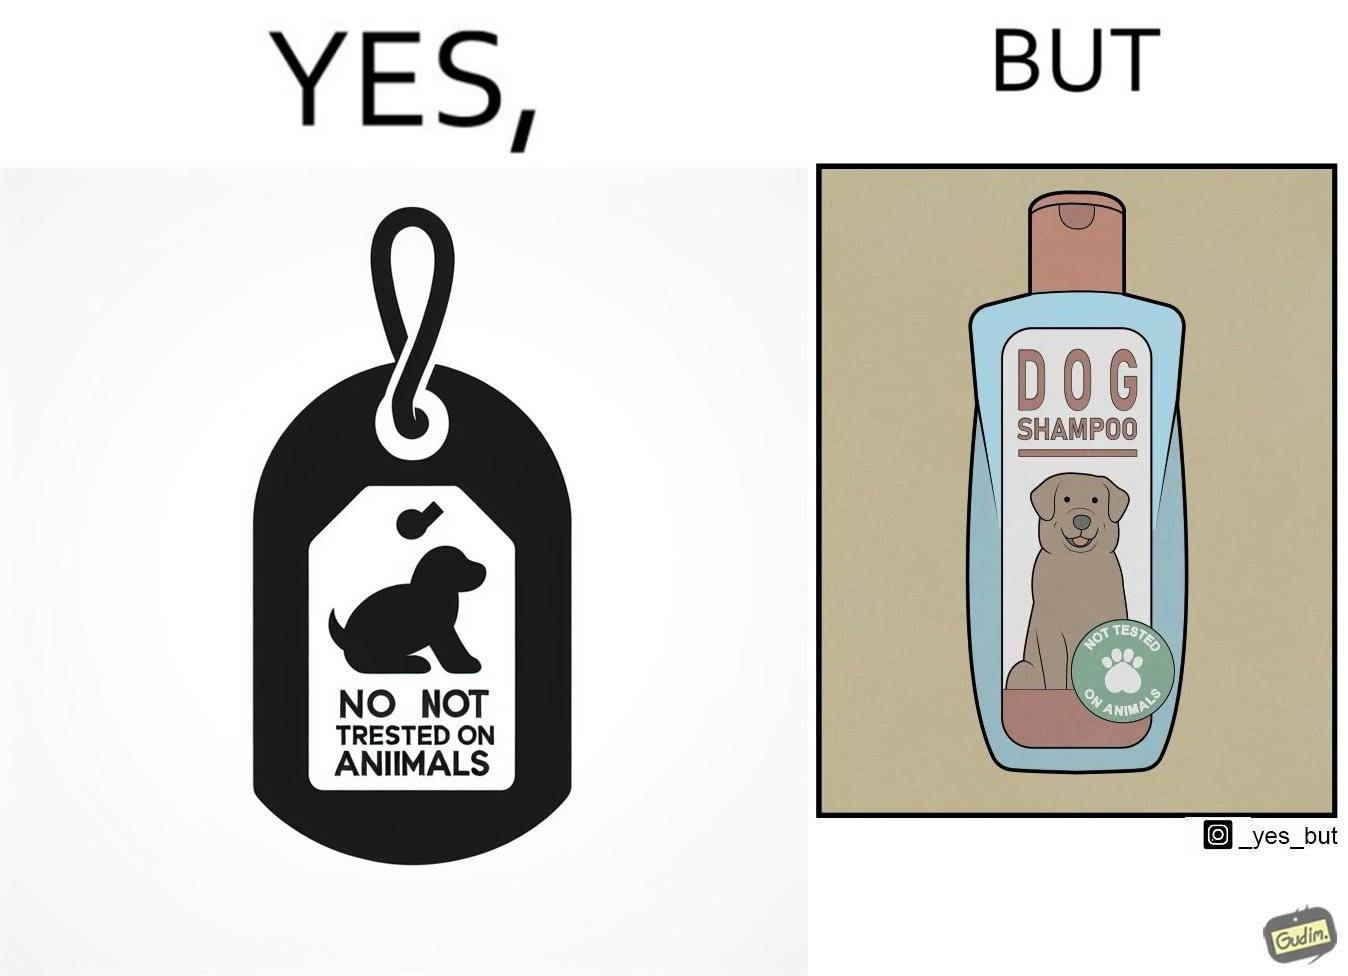Explain why this image is satirical. The images are ironic since a dog shampoo bottle has a sticker indicating that it has not been tested on animals and hence might not be safe for animal use. It is amusing that a product designed to be used by animals is not tested on animals for their safety 